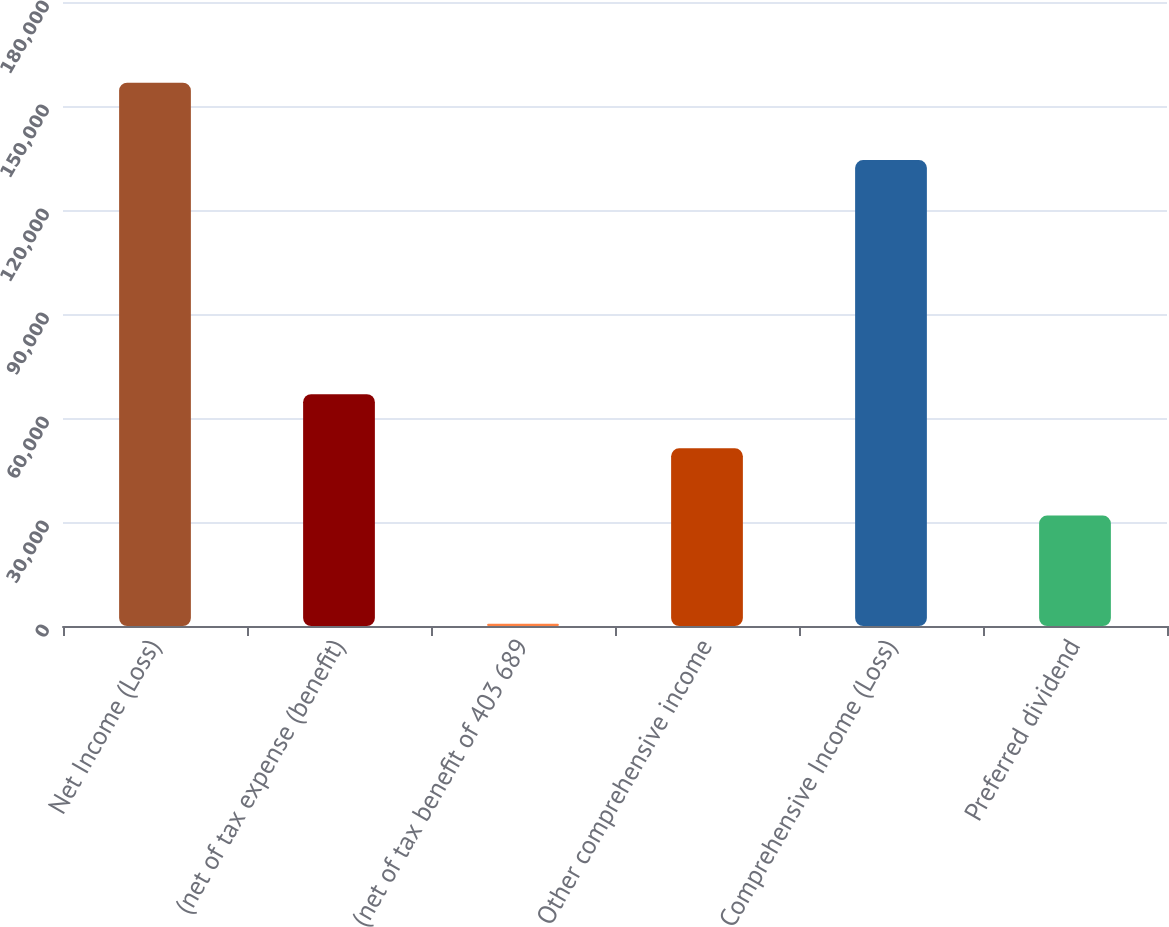Convert chart to OTSL. <chart><loc_0><loc_0><loc_500><loc_500><bar_chart><fcel>Net Income (Loss)<fcel>(net of tax expense (benefit)<fcel>(net of tax benefit of 403 689<fcel>Other comprehensive income<fcel>Comprehensive Income (Loss)<fcel>Preferred dividend<nl><fcel>156734<fcel>66867.3<fcel>641<fcel>51258<fcel>134404<fcel>31859.6<nl></chart> 